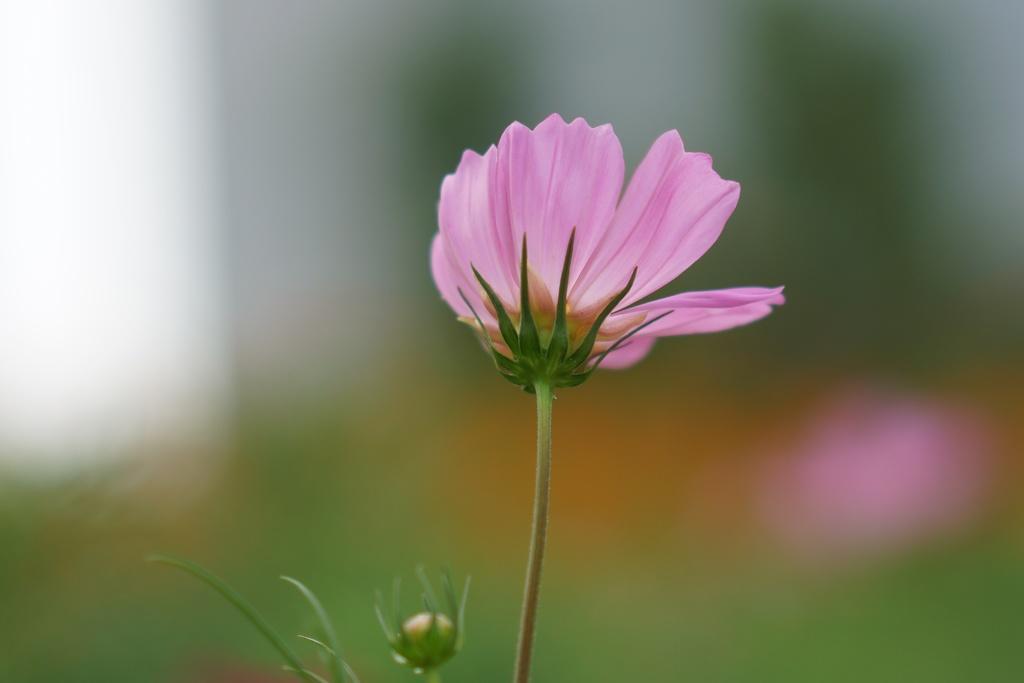In one or two sentences, can you explain what this image depicts? In this image we can see pink color flower and stem. 